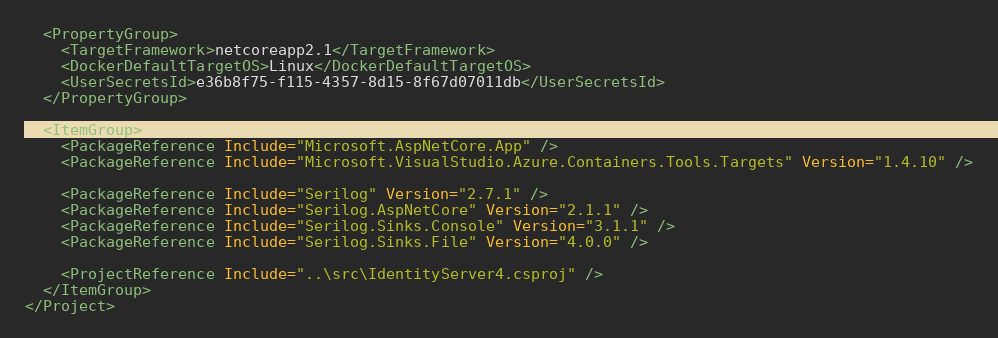<code> <loc_0><loc_0><loc_500><loc_500><_XML_>  <PropertyGroup>
    <TargetFramework>netcoreapp2.1</TargetFramework>
    <DockerDefaultTargetOS>Linux</DockerDefaultTargetOS>
    <UserSecretsId>e36b8f75-f115-4357-8d15-8f67d07011db</UserSecretsId>
  </PropertyGroup>

  <ItemGroup>
    <PackageReference Include="Microsoft.AspNetCore.App" />
    <PackageReference Include="Microsoft.VisualStudio.Azure.Containers.Tools.Targets" Version="1.4.10" />
    
    <PackageReference Include="Serilog" Version="2.7.1" />
    <PackageReference Include="Serilog.AspNetCore" Version="2.1.1" />
    <PackageReference Include="Serilog.Sinks.Console" Version="3.1.1" />
    <PackageReference Include="Serilog.Sinks.File" Version="4.0.0" />

    <ProjectReference Include="..\src\IdentityServer4.csproj" />
  </ItemGroup>
</Project></code> 